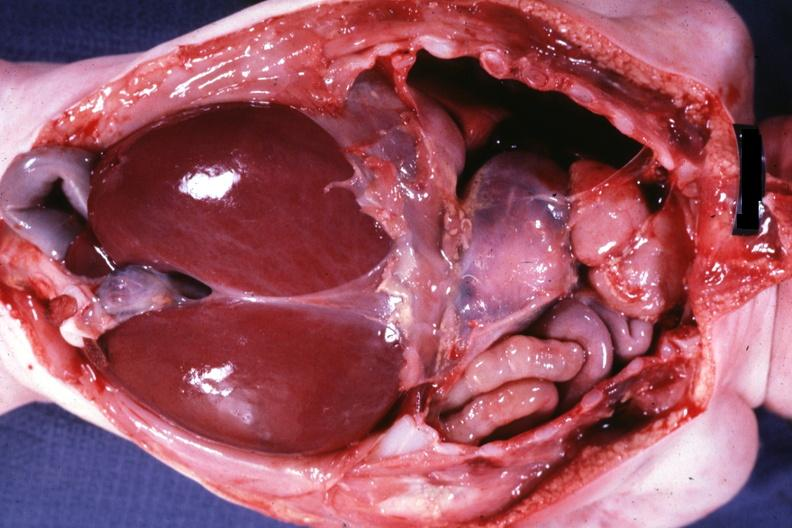s muscle present?
Answer the question using a single word or phrase. Yes 